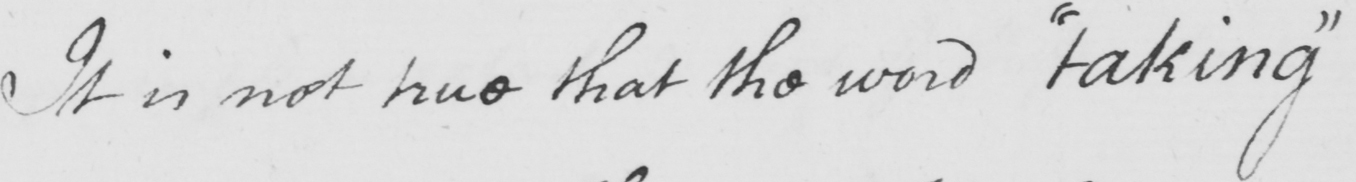Can you tell me what this handwritten text says? It is not true that the word  " taking " 